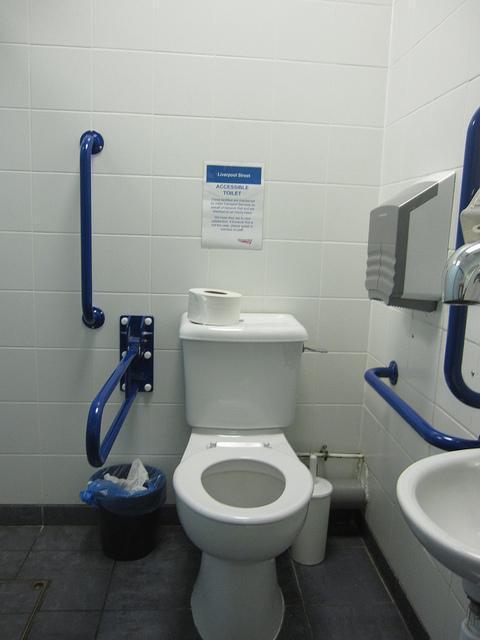How many trash cans are present?
Give a very brief answer. 1. 